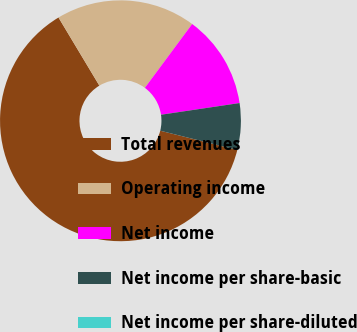Convert chart. <chart><loc_0><loc_0><loc_500><loc_500><pie_chart><fcel>Total revenues<fcel>Operating income<fcel>Net income<fcel>Net income per share-basic<fcel>Net income per share-diluted<nl><fcel>62.5%<fcel>18.75%<fcel>12.5%<fcel>6.25%<fcel>0.0%<nl></chart> 